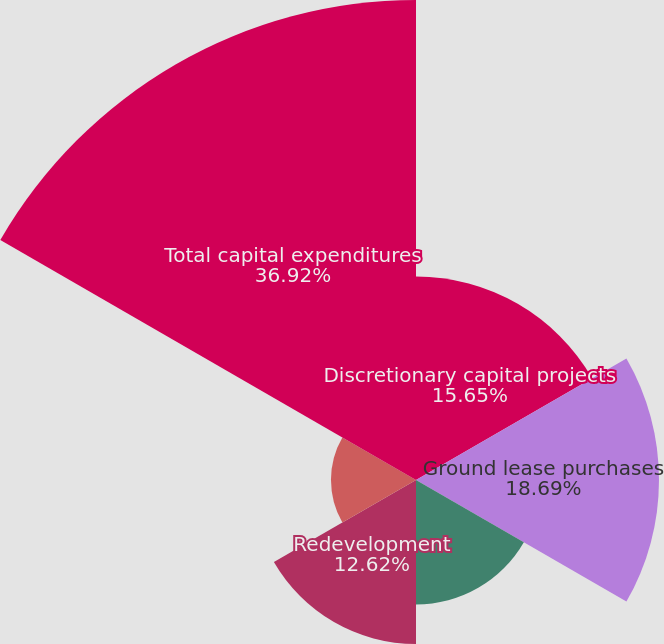<chart> <loc_0><loc_0><loc_500><loc_500><pie_chart><fcel>Discretionary capital projects<fcel>Ground lease purchases<fcel>Capital improvements and<fcel>Redevelopment<fcel>Start-up capital projects<fcel>Total capital expenditures<nl><fcel>15.65%<fcel>18.69%<fcel>9.58%<fcel>12.62%<fcel>6.54%<fcel>36.92%<nl></chart> 